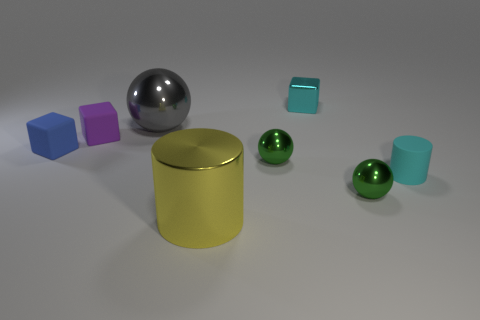Add 1 small matte things. How many objects exist? 9 Subtract all blocks. How many objects are left? 5 Add 6 large yellow shiny cylinders. How many large yellow shiny cylinders exist? 7 Subtract 0 red spheres. How many objects are left? 8 Subtract all small cylinders. Subtract all tiny green things. How many objects are left? 5 Add 4 tiny green shiny spheres. How many tiny green shiny spheres are left? 6 